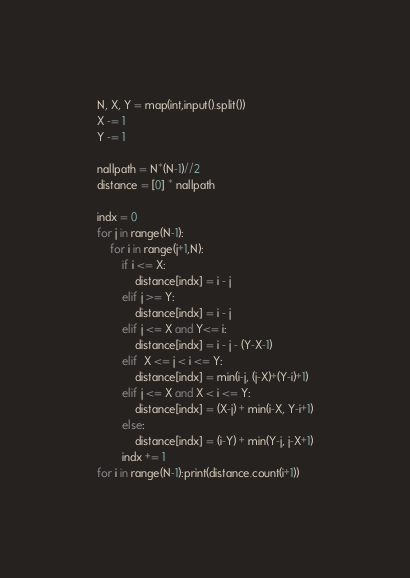<code> <loc_0><loc_0><loc_500><loc_500><_Python_>N, X, Y = map(int,input().split())
X -= 1
Y -= 1

nallpath = N*(N-1)//2
distance = [0] * nallpath

indx = 0
for j in range(N-1):
    for i in range(j+1,N):
        if i <= X:
            distance[indx] = i - j
        elif j >= Y:
            distance[indx] = i - j
        elif j <= X and Y<= i:
            distance[indx] = i - j - (Y-X-1)
        elif  X <= j < i <= Y:
            distance[indx] = min(i-j, (j-X)+(Y-i)+1)
        elif j <= X and X < i <= Y:
            distance[indx] = (X-j) + min(i-X, Y-i+1)
        else:
            distance[indx] = (i-Y) + min(Y-j, j-X+1)
        indx += 1
for i in range(N-1):print(distance.count(i+1))</code> 